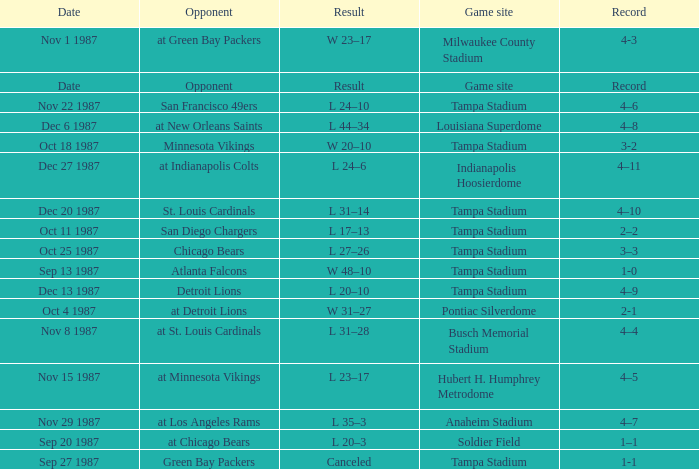Who was the Opponent at the Game Site Indianapolis Hoosierdome? At indianapolis colts. 